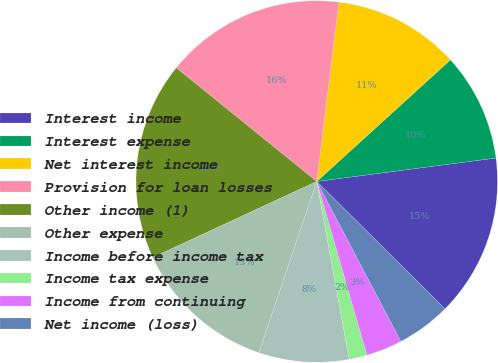Convert chart. <chart><loc_0><loc_0><loc_500><loc_500><pie_chart><fcel>Interest income<fcel>Interest expense<fcel>Net interest income<fcel>Provision for loan losses<fcel>Other income (1)<fcel>Other expense<fcel>Income before income tax<fcel>Income tax expense<fcel>Income from continuing<fcel>Net income (loss)<nl><fcel>14.52%<fcel>9.68%<fcel>11.29%<fcel>16.13%<fcel>17.74%<fcel>12.9%<fcel>8.06%<fcel>1.61%<fcel>3.23%<fcel>4.84%<nl></chart> 